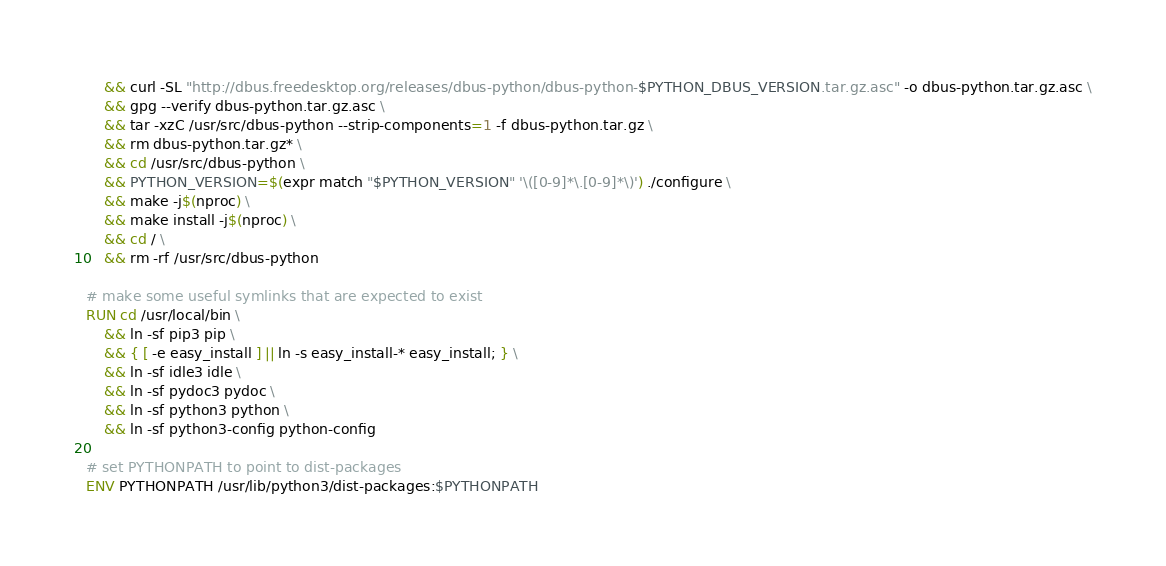Convert code to text. <code><loc_0><loc_0><loc_500><loc_500><_Dockerfile_>	&& curl -SL "http://dbus.freedesktop.org/releases/dbus-python/dbus-python-$PYTHON_DBUS_VERSION.tar.gz.asc" -o dbus-python.tar.gz.asc \
	&& gpg --verify dbus-python.tar.gz.asc \
	&& tar -xzC /usr/src/dbus-python --strip-components=1 -f dbus-python.tar.gz \
	&& rm dbus-python.tar.gz* \
	&& cd /usr/src/dbus-python \
	&& PYTHON_VERSION=$(expr match "$PYTHON_VERSION" '\([0-9]*\.[0-9]*\)') ./configure \
	&& make -j$(nproc) \
	&& make install -j$(nproc) \
	&& cd / \
	&& rm -rf /usr/src/dbus-python

# make some useful symlinks that are expected to exist
RUN cd /usr/local/bin \
	&& ln -sf pip3 pip \
	&& { [ -e easy_install ] || ln -s easy_install-* easy_install; } \
	&& ln -sf idle3 idle \
	&& ln -sf pydoc3 pydoc \
	&& ln -sf python3 python \
	&& ln -sf python3-config python-config

# set PYTHONPATH to point to dist-packages
ENV PYTHONPATH /usr/lib/python3/dist-packages:$PYTHONPATH
</code> 